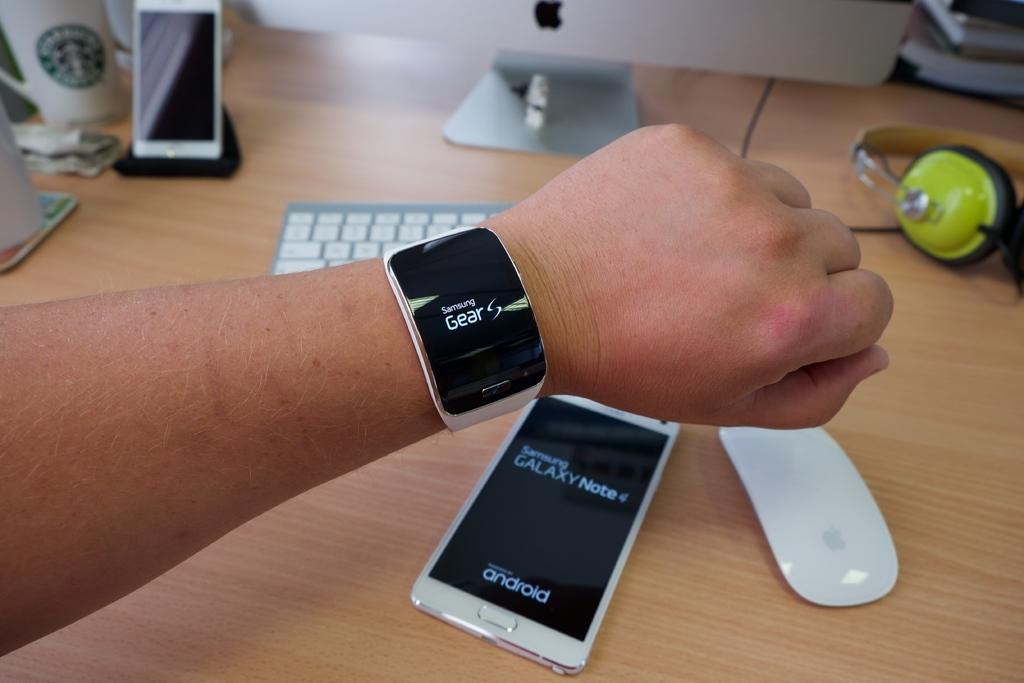Provide a one-sentence caption for the provided image. A person wearing a Samsung Gear watch holds its above a Samsung mobile as if to demonstrate that the two can work in tandem. 